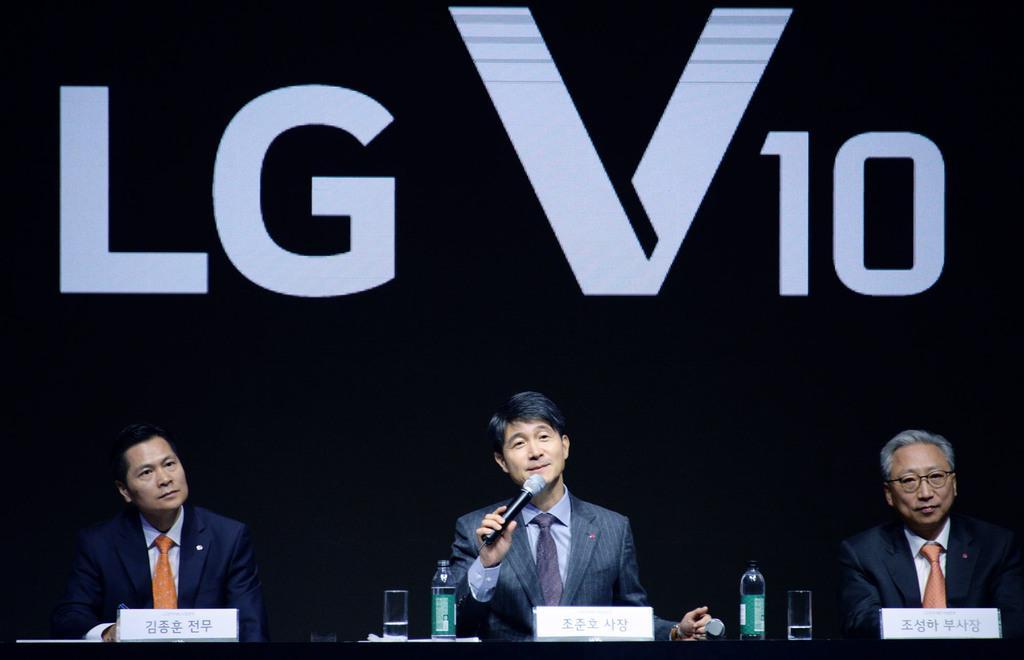Can you describe this image briefly? In front of the image there is a person holding a mic is sitting in a chair, beside the person there are two other people sitting in chairs, in front of them on the table there are bottles of water, glasses, name plates, behind them there is some text on the banner. 